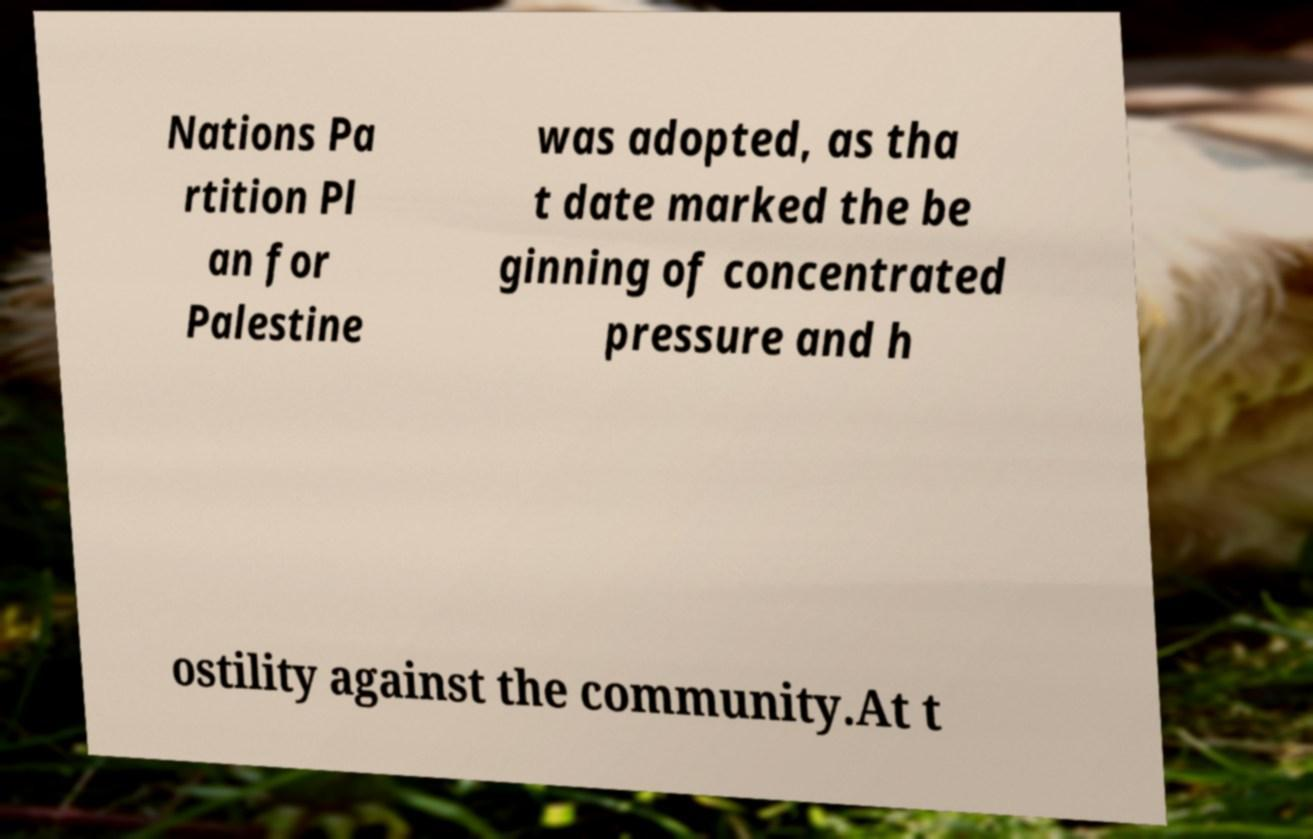Can you read and provide the text displayed in the image?This photo seems to have some interesting text. Can you extract and type it out for me? Nations Pa rtition Pl an for Palestine was adopted, as tha t date marked the be ginning of concentrated pressure and h ostility against the community.At t 